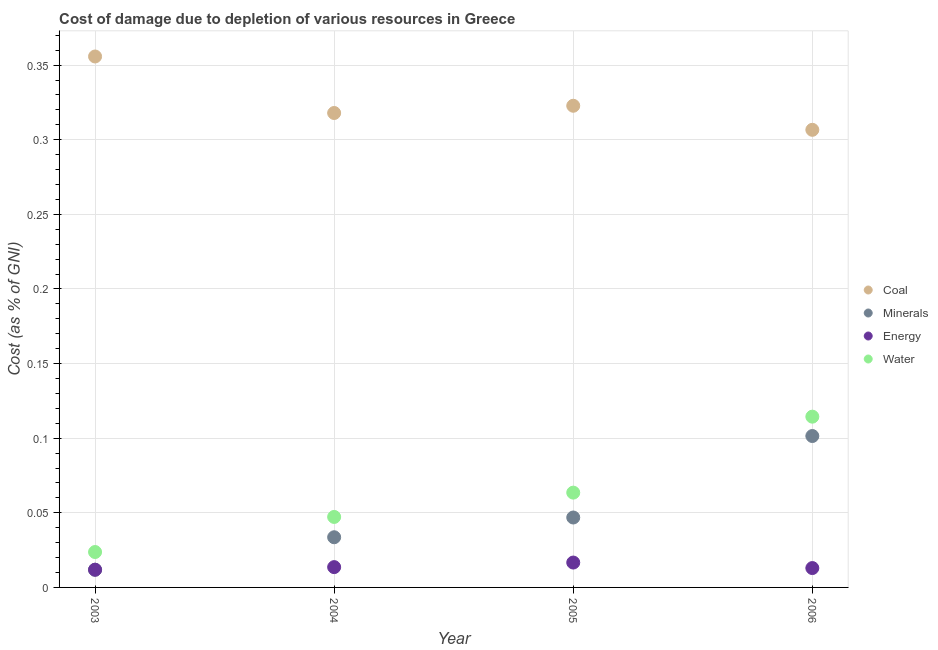What is the cost of damage due to depletion of coal in 2006?
Offer a very short reply. 0.31. Across all years, what is the maximum cost of damage due to depletion of water?
Offer a terse response. 0.11. Across all years, what is the minimum cost of damage due to depletion of energy?
Give a very brief answer. 0.01. In which year was the cost of damage due to depletion of energy maximum?
Give a very brief answer. 2005. In which year was the cost of damage due to depletion of water minimum?
Keep it short and to the point. 2003. What is the total cost of damage due to depletion of energy in the graph?
Your response must be concise. 0.06. What is the difference between the cost of damage due to depletion of minerals in 2003 and that in 2005?
Ensure brevity in your answer.  -0.03. What is the difference between the cost of damage due to depletion of minerals in 2006 and the cost of damage due to depletion of water in 2004?
Keep it short and to the point. 0.05. What is the average cost of damage due to depletion of minerals per year?
Give a very brief answer. 0.05. In the year 2005, what is the difference between the cost of damage due to depletion of energy and cost of damage due to depletion of water?
Make the answer very short. -0.05. In how many years, is the cost of damage due to depletion of energy greater than 0.14 %?
Give a very brief answer. 0. What is the ratio of the cost of damage due to depletion of minerals in 2005 to that in 2006?
Your response must be concise. 0.46. Is the cost of damage due to depletion of energy in 2003 less than that in 2006?
Give a very brief answer. Yes. What is the difference between the highest and the second highest cost of damage due to depletion of energy?
Your answer should be very brief. 0. What is the difference between the highest and the lowest cost of damage due to depletion of minerals?
Ensure brevity in your answer.  0.09. In how many years, is the cost of damage due to depletion of coal greater than the average cost of damage due to depletion of coal taken over all years?
Keep it short and to the point. 1. Is the sum of the cost of damage due to depletion of minerals in 2003 and 2006 greater than the maximum cost of damage due to depletion of energy across all years?
Ensure brevity in your answer.  Yes. Does the cost of damage due to depletion of water monotonically increase over the years?
Your response must be concise. Yes. Is the cost of damage due to depletion of coal strictly greater than the cost of damage due to depletion of energy over the years?
Your answer should be very brief. Yes. Is the cost of damage due to depletion of coal strictly less than the cost of damage due to depletion of minerals over the years?
Ensure brevity in your answer.  No. How many dotlines are there?
Offer a very short reply. 4. How many years are there in the graph?
Provide a succinct answer. 4. Are the values on the major ticks of Y-axis written in scientific E-notation?
Your answer should be very brief. No. How many legend labels are there?
Provide a succinct answer. 4. How are the legend labels stacked?
Your answer should be compact. Vertical. What is the title of the graph?
Your response must be concise. Cost of damage due to depletion of various resources in Greece . What is the label or title of the X-axis?
Ensure brevity in your answer.  Year. What is the label or title of the Y-axis?
Offer a very short reply. Cost (as % of GNI). What is the Cost (as % of GNI) of Coal in 2003?
Give a very brief answer. 0.36. What is the Cost (as % of GNI) of Minerals in 2003?
Your response must be concise. 0.01. What is the Cost (as % of GNI) in Energy in 2003?
Offer a terse response. 0.01. What is the Cost (as % of GNI) in Water in 2003?
Provide a short and direct response. 0.02. What is the Cost (as % of GNI) of Coal in 2004?
Offer a terse response. 0.32. What is the Cost (as % of GNI) of Minerals in 2004?
Ensure brevity in your answer.  0.03. What is the Cost (as % of GNI) of Energy in 2004?
Keep it short and to the point. 0.01. What is the Cost (as % of GNI) in Water in 2004?
Offer a very short reply. 0.05. What is the Cost (as % of GNI) in Coal in 2005?
Provide a succinct answer. 0.32. What is the Cost (as % of GNI) of Minerals in 2005?
Ensure brevity in your answer.  0.05. What is the Cost (as % of GNI) in Energy in 2005?
Your answer should be very brief. 0.02. What is the Cost (as % of GNI) of Water in 2005?
Offer a very short reply. 0.06. What is the Cost (as % of GNI) of Coal in 2006?
Provide a succinct answer. 0.31. What is the Cost (as % of GNI) of Minerals in 2006?
Provide a short and direct response. 0.1. What is the Cost (as % of GNI) of Energy in 2006?
Ensure brevity in your answer.  0.01. What is the Cost (as % of GNI) of Water in 2006?
Offer a very short reply. 0.11. Across all years, what is the maximum Cost (as % of GNI) in Coal?
Provide a succinct answer. 0.36. Across all years, what is the maximum Cost (as % of GNI) in Minerals?
Offer a terse response. 0.1. Across all years, what is the maximum Cost (as % of GNI) in Energy?
Provide a short and direct response. 0.02. Across all years, what is the maximum Cost (as % of GNI) in Water?
Give a very brief answer. 0.11. Across all years, what is the minimum Cost (as % of GNI) in Coal?
Give a very brief answer. 0.31. Across all years, what is the minimum Cost (as % of GNI) of Minerals?
Ensure brevity in your answer.  0.01. Across all years, what is the minimum Cost (as % of GNI) in Energy?
Provide a succinct answer. 0.01. Across all years, what is the minimum Cost (as % of GNI) of Water?
Ensure brevity in your answer.  0.02. What is the total Cost (as % of GNI) in Coal in the graph?
Make the answer very short. 1.3. What is the total Cost (as % of GNI) of Minerals in the graph?
Give a very brief answer. 0.19. What is the total Cost (as % of GNI) of Energy in the graph?
Make the answer very short. 0.06. What is the total Cost (as % of GNI) in Water in the graph?
Give a very brief answer. 0.25. What is the difference between the Cost (as % of GNI) in Coal in 2003 and that in 2004?
Make the answer very short. 0.04. What is the difference between the Cost (as % of GNI) of Minerals in 2003 and that in 2004?
Your response must be concise. -0.02. What is the difference between the Cost (as % of GNI) in Energy in 2003 and that in 2004?
Keep it short and to the point. -0. What is the difference between the Cost (as % of GNI) of Water in 2003 and that in 2004?
Your answer should be very brief. -0.02. What is the difference between the Cost (as % of GNI) of Coal in 2003 and that in 2005?
Offer a terse response. 0.03. What is the difference between the Cost (as % of GNI) in Minerals in 2003 and that in 2005?
Provide a succinct answer. -0.04. What is the difference between the Cost (as % of GNI) of Energy in 2003 and that in 2005?
Provide a short and direct response. -0. What is the difference between the Cost (as % of GNI) of Water in 2003 and that in 2005?
Your answer should be very brief. -0.04. What is the difference between the Cost (as % of GNI) in Coal in 2003 and that in 2006?
Keep it short and to the point. 0.05. What is the difference between the Cost (as % of GNI) in Minerals in 2003 and that in 2006?
Your answer should be very brief. -0.09. What is the difference between the Cost (as % of GNI) of Energy in 2003 and that in 2006?
Your answer should be compact. -0. What is the difference between the Cost (as % of GNI) of Water in 2003 and that in 2006?
Provide a succinct answer. -0.09. What is the difference between the Cost (as % of GNI) in Coal in 2004 and that in 2005?
Your answer should be compact. -0. What is the difference between the Cost (as % of GNI) in Minerals in 2004 and that in 2005?
Provide a succinct answer. -0.01. What is the difference between the Cost (as % of GNI) of Energy in 2004 and that in 2005?
Ensure brevity in your answer.  -0. What is the difference between the Cost (as % of GNI) in Water in 2004 and that in 2005?
Provide a short and direct response. -0.02. What is the difference between the Cost (as % of GNI) in Coal in 2004 and that in 2006?
Keep it short and to the point. 0.01. What is the difference between the Cost (as % of GNI) in Minerals in 2004 and that in 2006?
Ensure brevity in your answer.  -0.07. What is the difference between the Cost (as % of GNI) in Energy in 2004 and that in 2006?
Make the answer very short. 0. What is the difference between the Cost (as % of GNI) in Water in 2004 and that in 2006?
Make the answer very short. -0.07. What is the difference between the Cost (as % of GNI) in Coal in 2005 and that in 2006?
Ensure brevity in your answer.  0.02. What is the difference between the Cost (as % of GNI) of Minerals in 2005 and that in 2006?
Your answer should be compact. -0.05. What is the difference between the Cost (as % of GNI) of Energy in 2005 and that in 2006?
Your response must be concise. 0. What is the difference between the Cost (as % of GNI) of Water in 2005 and that in 2006?
Provide a short and direct response. -0.05. What is the difference between the Cost (as % of GNI) of Coal in 2003 and the Cost (as % of GNI) of Minerals in 2004?
Offer a terse response. 0.32. What is the difference between the Cost (as % of GNI) in Coal in 2003 and the Cost (as % of GNI) in Energy in 2004?
Offer a very short reply. 0.34. What is the difference between the Cost (as % of GNI) in Coal in 2003 and the Cost (as % of GNI) in Water in 2004?
Ensure brevity in your answer.  0.31. What is the difference between the Cost (as % of GNI) in Minerals in 2003 and the Cost (as % of GNI) in Energy in 2004?
Offer a terse response. -0. What is the difference between the Cost (as % of GNI) of Minerals in 2003 and the Cost (as % of GNI) of Water in 2004?
Your response must be concise. -0.04. What is the difference between the Cost (as % of GNI) of Energy in 2003 and the Cost (as % of GNI) of Water in 2004?
Give a very brief answer. -0.04. What is the difference between the Cost (as % of GNI) of Coal in 2003 and the Cost (as % of GNI) of Minerals in 2005?
Offer a very short reply. 0.31. What is the difference between the Cost (as % of GNI) of Coal in 2003 and the Cost (as % of GNI) of Energy in 2005?
Make the answer very short. 0.34. What is the difference between the Cost (as % of GNI) of Coal in 2003 and the Cost (as % of GNI) of Water in 2005?
Offer a very short reply. 0.29. What is the difference between the Cost (as % of GNI) of Minerals in 2003 and the Cost (as % of GNI) of Energy in 2005?
Keep it short and to the point. -0. What is the difference between the Cost (as % of GNI) of Minerals in 2003 and the Cost (as % of GNI) of Water in 2005?
Offer a very short reply. -0.05. What is the difference between the Cost (as % of GNI) of Energy in 2003 and the Cost (as % of GNI) of Water in 2005?
Offer a very short reply. -0.05. What is the difference between the Cost (as % of GNI) of Coal in 2003 and the Cost (as % of GNI) of Minerals in 2006?
Your answer should be compact. 0.25. What is the difference between the Cost (as % of GNI) of Coal in 2003 and the Cost (as % of GNI) of Energy in 2006?
Offer a very short reply. 0.34. What is the difference between the Cost (as % of GNI) in Coal in 2003 and the Cost (as % of GNI) in Water in 2006?
Your response must be concise. 0.24. What is the difference between the Cost (as % of GNI) in Minerals in 2003 and the Cost (as % of GNI) in Energy in 2006?
Make the answer very short. -0. What is the difference between the Cost (as % of GNI) in Minerals in 2003 and the Cost (as % of GNI) in Water in 2006?
Offer a terse response. -0.1. What is the difference between the Cost (as % of GNI) in Energy in 2003 and the Cost (as % of GNI) in Water in 2006?
Your response must be concise. -0.1. What is the difference between the Cost (as % of GNI) in Coal in 2004 and the Cost (as % of GNI) in Minerals in 2005?
Give a very brief answer. 0.27. What is the difference between the Cost (as % of GNI) of Coal in 2004 and the Cost (as % of GNI) of Energy in 2005?
Your answer should be compact. 0.3. What is the difference between the Cost (as % of GNI) in Coal in 2004 and the Cost (as % of GNI) in Water in 2005?
Your response must be concise. 0.25. What is the difference between the Cost (as % of GNI) in Minerals in 2004 and the Cost (as % of GNI) in Energy in 2005?
Offer a terse response. 0.02. What is the difference between the Cost (as % of GNI) in Minerals in 2004 and the Cost (as % of GNI) in Water in 2005?
Keep it short and to the point. -0.03. What is the difference between the Cost (as % of GNI) of Energy in 2004 and the Cost (as % of GNI) of Water in 2005?
Ensure brevity in your answer.  -0.05. What is the difference between the Cost (as % of GNI) in Coal in 2004 and the Cost (as % of GNI) in Minerals in 2006?
Provide a succinct answer. 0.22. What is the difference between the Cost (as % of GNI) in Coal in 2004 and the Cost (as % of GNI) in Energy in 2006?
Your answer should be very brief. 0.3. What is the difference between the Cost (as % of GNI) in Coal in 2004 and the Cost (as % of GNI) in Water in 2006?
Offer a terse response. 0.2. What is the difference between the Cost (as % of GNI) in Minerals in 2004 and the Cost (as % of GNI) in Energy in 2006?
Your answer should be compact. 0.02. What is the difference between the Cost (as % of GNI) in Minerals in 2004 and the Cost (as % of GNI) in Water in 2006?
Ensure brevity in your answer.  -0.08. What is the difference between the Cost (as % of GNI) in Energy in 2004 and the Cost (as % of GNI) in Water in 2006?
Offer a very short reply. -0.1. What is the difference between the Cost (as % of GNI) in Coal in 2005 and the Cost (as % of GNI) in Minerals in 2006?
Make the answer very short. 0.22. What is the difference between the Cost (as % of GNI) of Coal in 2005 and the Cost (as % of GNI) of Energy in 2006?
Make the answer very short. 0.31. What is the difference between the Cost (as % of GNI) in Coal in 2005 and the Cost (as % of GNI) in Water in 2006?
Offer a terse response. 0.21. What is the difference between the Cost (as % of GNI) of Minerals in 2005 and the Cost (as % of GNI) of Energy in 2006?
Make the answer very short. 0.03. What is the difference between the Cost (as % of GNI) of Minerals in 2005 and the Cost (as % of GNI) of Water in 2006?
Make the answer very short. -0.07. What is the difference between the Cost (as % of GNI) of Energy in 2005 and the Cost (as % of GNI) of Water in 2006?
Make the answer very short. -0.1. What is the average Cost (as % of GNI) in Coal per year?
Give a very brief answer. 0.33. What is the average Cost (as % of GNI) in Minerals per year?
Your answer should be very brief. 0.05. What is the average Cost (as % of GNI) in Energy per year?
Your response must be concise. 0.01. What is the average Cost (as % of GNI) in Water per year?
Give a very brief answer. 0.06. In the year 2003, what is the difference between the Cost (as % of GNI) of Coal and Cost (as % of GNI) of Minerals?
Provide a short and direct response. 0.34. In the year 2003, what is the difference between the Cost (as % of GNI) of Coal and Cost (as % of GNI) of Energy?
Offer a very short reply. 0.34. In the year 2003, what is the difference between the Cost (as % of GNI) of Coal and Cost (as % of GNI) of Water?
Your answer should be compact. 0.33. In the year 2003, what is the difference between the Cost (as % of GNI) in Minerals and Cost (as % of GNI) in Water?
Your answer should be compact. -0.01. In the year 2003, what is the difference between the Cost (as % of GNI) of Energy and Cost (as % of GNI) of Water?
Give a very brief answer. -0.01. In the year 2004, what is the difference between the Cost (as % of GNI) in Coal and Cost (as % of GNI) in Minerals?
Your answer should be compact. 0.28. In the year 2004, what is the difference between the Cost (as % of GNI) of Coal and Cost (as % of GNI) of Energy?
Your answer should be very brief. 0.3. In the year 2004, what is the difference between the Cost (as % of GNI) of Coal and Cost (as % of GNI) of Water?
Provide a succinct answer. 0.27. In the year 2004, what is the difference between the Cost (as % of GNI) of Minerals and Cost (as % of GNI) of Energy?
Give a very brief answer. 0.02. In the year 2004, what is the difference between the Cost (as % of GNI) in Minerals and Cost (as % of GNI) in Water?
Your answer should be compact. -0.01. In the year 2004, what is the difference between the Cost (as % of GNI) of Energy and Cost (as % of GNI) of Water?
Your answer should be compact. -0.03. In the year 2005, what is the difference between the Cost (as % of GNI) of Coal and Cost (as % of GNI) of Minerals?
Your answer should be compact. 0.28. In the year 2005, what is the difference between the Cost (as % of GNI) in Coal and Cost (as % of GNI) in Energy?
Offer a very short reply. 0.31. In the year 2005, what is the difference between the Cost (as % of GNI) of Coal and Cost (as % of GNI) of Water?
Your answer should be very brief. 0.26. In the year 2005, what is the difference between the Cost (as % of GNI) in Minerals and Cost (as % of GNI) in Energy?
Offer a terse response. 0.03. In the year 2005, what is the difference between the Cost (as % of GNI) in Minerals and Cost (as % of GNI) in Water?
Provide a short and direct response. -0.02. In the year 2005, what is the difference between the Cost (as % of GNI) of Energy and Cost (as % of GNI) of Water?
Make the answer very short. -0.05. In the year 2006, what is the difference between the Cost (as % of GNI) in Coal and Cost (as % of GNI) in Minerals?
Your answer should be compact. 0.21. In the year 2006, what is the difference between the Cost (as % of GNI) in Coal and Cost (as % of GNI) in Energy?
Ensure brevity in your answer.  0.29. In the year 2006, what is the difference between the Cost (as % of GNI) of Coal and Cost (as % of GNI) of Water?
Your answer should be compact. 0.19. In the year 2006, what is the difference between the Cost (as % of GNI) of Minerals and Cost (as % of GNI) of Energy?
Keep it short and to the point. 0.09. In the year 2006, what is the difference between the Cost (as % of GNI) of Minerals and Cost (as % of GNI) of Water?
Ensure brevity in your answer.  -0.01. In the year 2006, what is the difference between the Cost (as % of GNI) of Energy and Cost (as % of GNI) of Water?
Your answer should be very brief. -0.1. What is the ratio of the Cost (as % of GNI) in Coal in 2003 to that in 2004?
Your answer should be very brief. 1.12. What is the ratio of the Cost (as % of GNI) of Minerals in 2003 to that in 2004?
Your answer should be very brief. 0.35. What is the ratio of the Cost (as % of GNI) of Energy in 2003 to that in 2004?
Provide a succinct answer. 0.87. What is the ratio of the Cost (as % of GNI) of Water in 2003 to that in 2004?
Your answer should be very brief. 0.5. What is the ratio of the Cost (as % of GNI) of Coal in 2003 to that in 2005?
Ensure brevity in your answer.  1.1. What is the ratio of the Cost (as % of GNI) of Minerals in 2003 to that in 2005?
Your answer should be compact. 0.25. What is the ratio of the Cost (as % of GNI) of Energy in 2003 to that in 2005?
Provide a succinct answer. 0.71. What is the ratio of the Cost (as % of GNI) of Water in 2003 to that in 2005?
Offer a very short reply. 0.37. What is the ratio of the Cost (as % of GNI) of Coal in 2003 to that in 2006?
Offer a terse response. 1.16. What is the ratio of the Cost (as % of GNI) of Minerals in 2003 to that in 2006?
Provide a short and direct response. 0.12. What is the ratio of the Cost (as % of GNI) in Energy in 2003 to that in 2006?
Your response must be concise. 0.91. What is the ratio of the Cost (as % of GNI) in Water in 2003 to that in 2006?
Provide a succinct answer. 0.21. What is the ratio of the Cost (as % of GNI) in Minerals in 2004 to that in 2005?
Your response must be concise. 0.72. What is the ratio of the Cost (as % of GNI) of Energy in 2004 to that in 2005?
Make the answer very short. 0.82. What is the ratio of the Cost (as % of GNI) of Water in 2004 to that in 2005?
Make the answer very short. 0.74. What is the ratio of the Cost (as % of GNI) of Coal in 2004 to that in 2006?
Your answer should be very brief. 1.04. What is the ratio of the Cost (as % of GNI) of Minerals in 2004 to that in 2006?
Provide a succinct answer. 0.33. What is the ratio of the Cost (as % of GNI) in Energy in 2004 to that in 2006?
Offer a very short reply. 1.05. What is the ratio of the Cost (as % of GNI) in Water in 2004 to that in 2006?
Give a very brief answer. 0.41. What is the ratio of the Cost (as % of GNI) in Coal in 2005 to that in 2006?
Ensure brevity in your answer.  1.05. What is the ratio of the Cost (as % of GNI) in Minerals in 2005 to that in 2006?
Provide a short and direct response. 0.46. What is the ratio of the Cost (as % of GNI) in Energy in 2005 to that in 2006?
Give a very brief answer. 1.28. What is the ratio of the Cost (as % of GNI) in Water in 2005 to that in 2006?
Your answer should be compact. 0.56. What is the difference between the highest and the second highest Cost (as % of GNI) in Coal?
Make the answer very short. 0.03. What is the difference between the highest and the second highest Cost (as % of GNI) of Minerals?
Make the answer very short. 0.05. What is the difference between the highest and the second highest Cost (as % of GNI) in Energy?
Provide a short and direct response. 0. What is the difference between the highest and the second highest Cost (as % of GNI) of Water?
Ensure brevity in your answer.  0.05. What is the difference between the highest and the lowest Cost (as % of GNI) in Coal?
Make the answer very short. 0.05. What is the difference between the highest and the lowest Cost (as % of GNI) in Minerals?
Provide a short and direct response. 0.09. What is the difference between the highest and the lowest Cost (as % of GNI) in Energy?
Your answer should be very brief. 0. What is the difference between the highest and the lowest Cost (as % of GNI) of Water?
Your answer should be very brief. 0.09. 